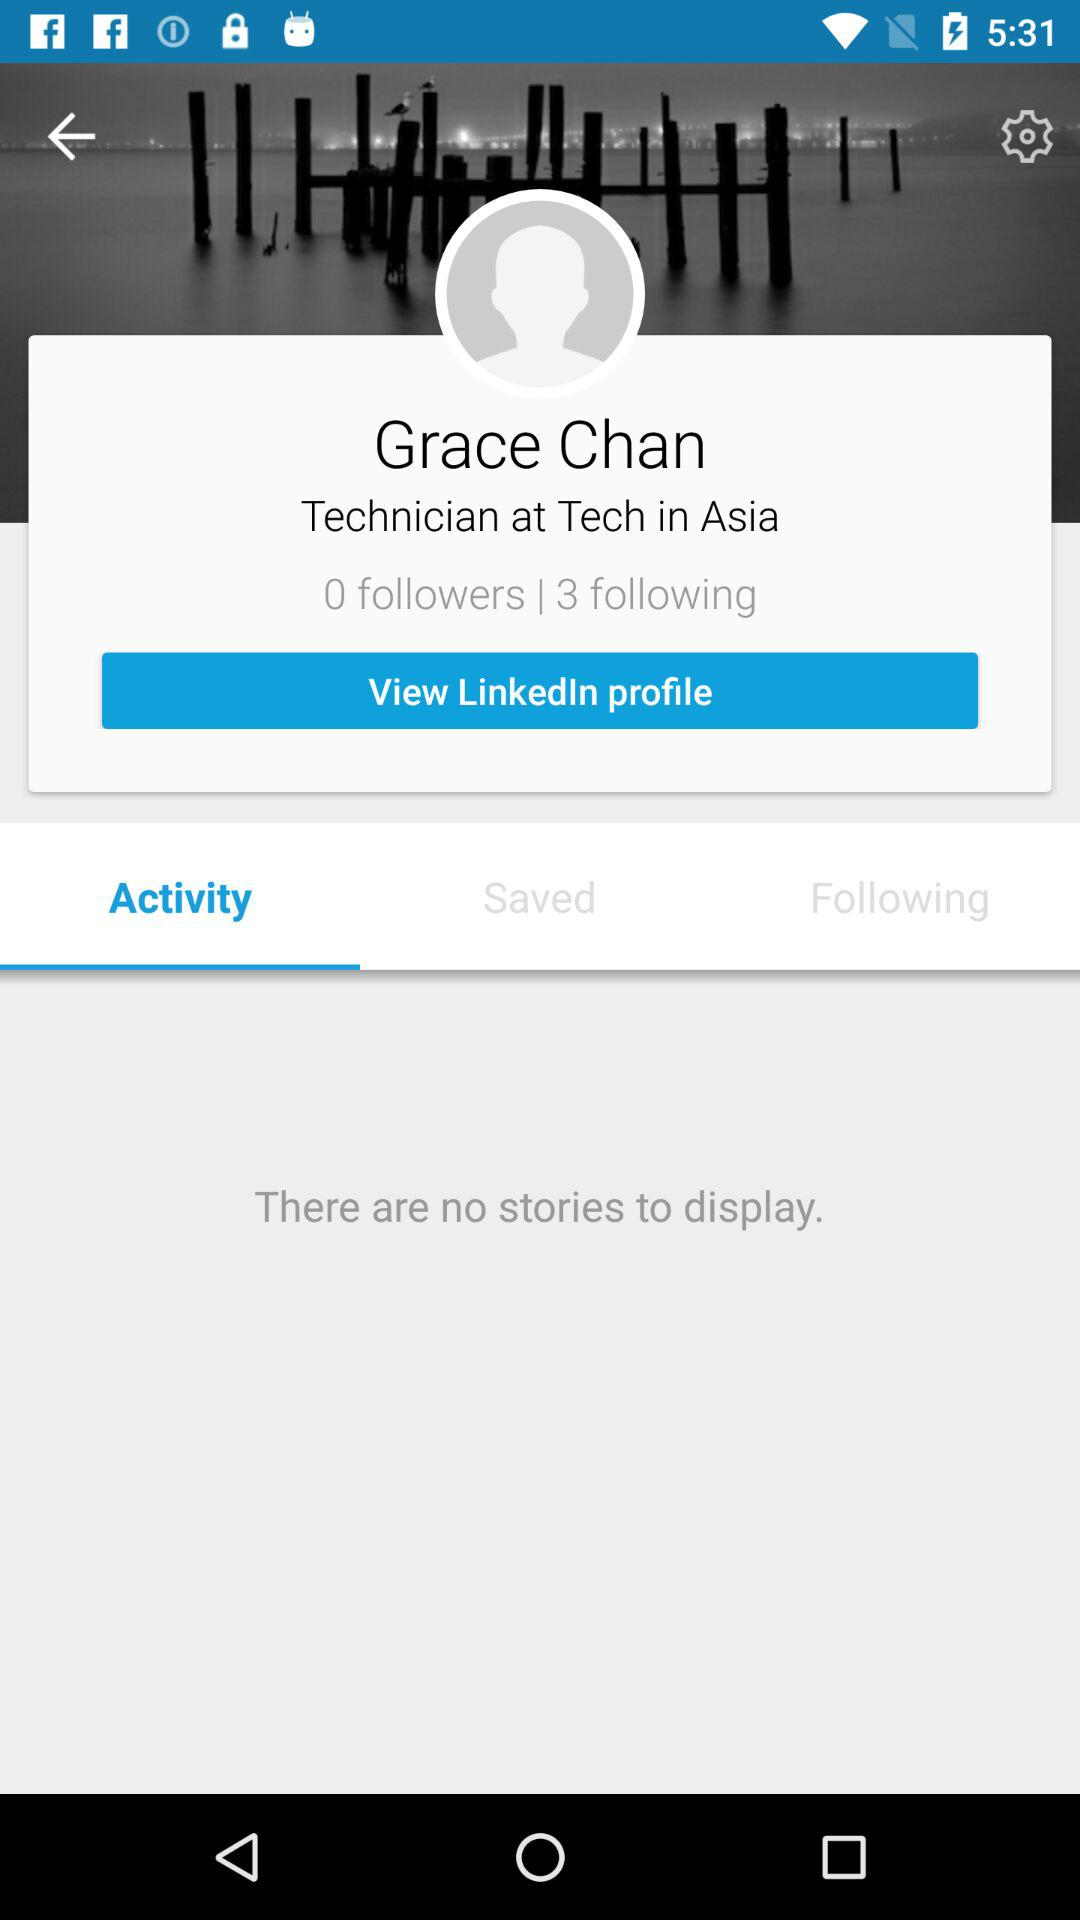What is the total number of stories on the screen?
Answer the question using a single word or phrase. 0 